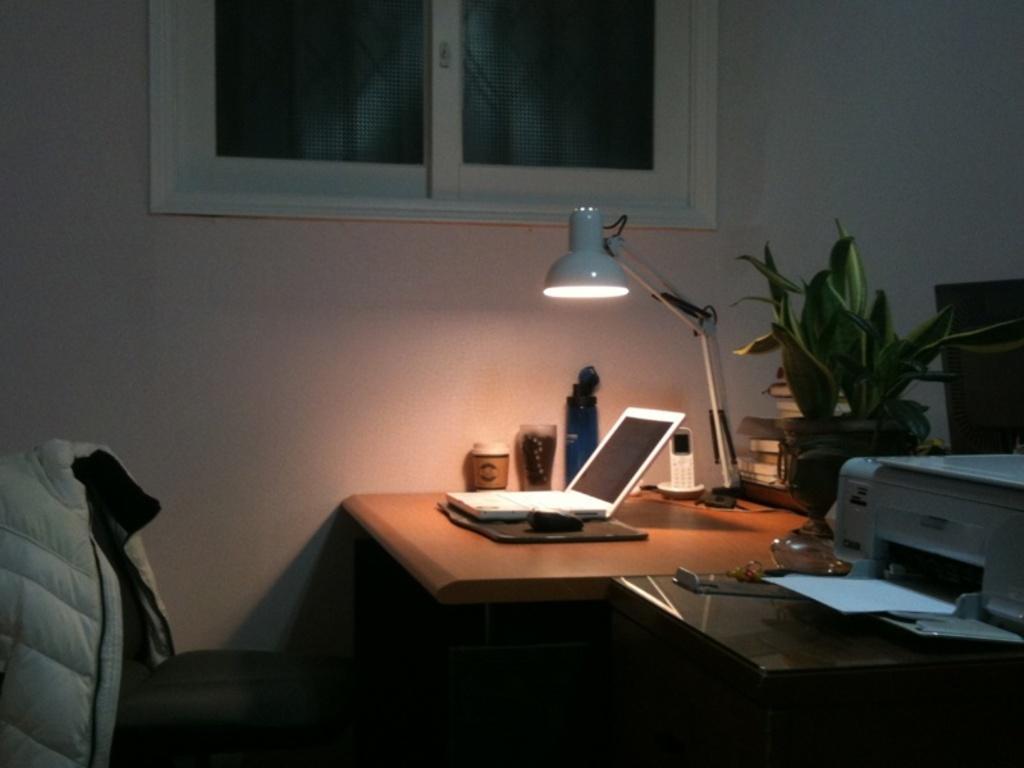Describe this image in one or two sentences. In this picture we can see a room with table and on table we have laptop, glass, lamp, phone, printer and aside to this table we have flower pot with plant in it , books, wall with window and here on chair we have a jacket. 